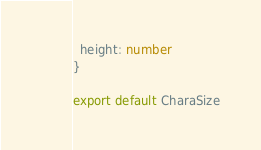<code> <loc_0><loc_0><loc_500><loc_500><_TypeScript_>  height: number
}

export default CharaSize
</code> 